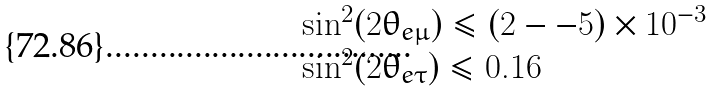<formula> <loc_0><loc_0><loc_500><loc_500>\begin{array} { l } \sin ^ { 2 } ( 2 \theta _ { e \mu } ) \leq ( 2 - - 5 ) \times 1 0 ^ { - 3 } \\ \sin ^ { 2 } ( 2 \theta _ { e \tau } ) \leq 0 . 1 6 \, \end{array}</formula> 